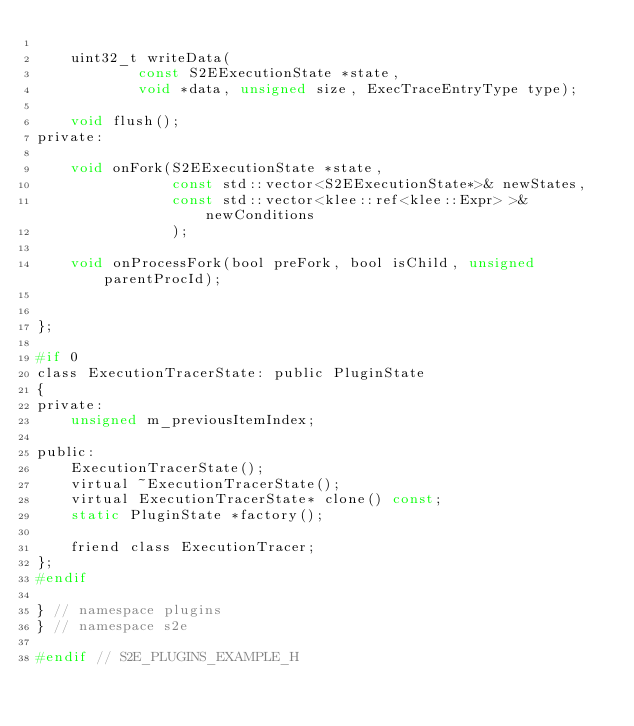Convert code to text. <code><loc_0><loc_0><loc_500><loc_500><_C_>
    uint32_t writeData(
            const S2EExecutionState *state,
            void *data, unsigned size, ExecTraceEntryType type);

    void flush();
private:

    void onFork(S2EExecutionState *state,
                const std::vector<S2EExecutionState*>& newStates,
                const std::vector<klee::ref<klee::Expr> >& newConditions
                );

    void onProcessFork(bool preFork, bool isChild, unsigned parentProcId);


};

#if 0
class ExecutionTracerState: public PluginState
{
private:
    unsigned m_previousItemIndex;

public:
    ExecutionTracerState();
    virtual ~ExecutionTracerState();
    virtual ExecutionTracerState* clone() const;
    static PluginState *factory();

    friend class ExecutionTracer;
};
#endif

} // namespace plugins
} // namespace s2e

#endif // S2E_PLUGINS_EXAMPLE_H
</code> 